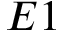<formula> <loc_0><loc_0><loc_500><loc_500>E 1</formula> 